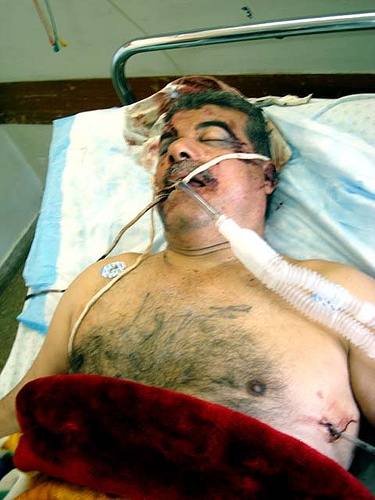Describe the objects in this image and their specific colors. I can see people in gray, tan, lightgray, and black tones and bed in gray, ivory, lightblue, darkgray, and beige tones in this image. 